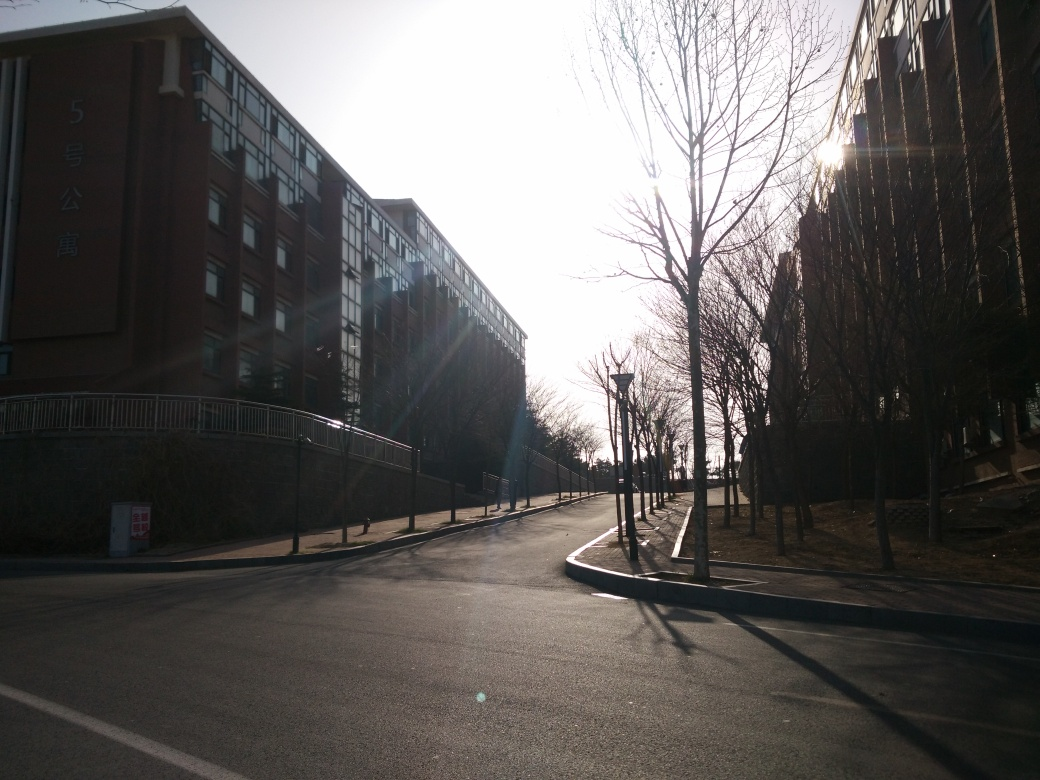What is the quality of the picture? The quality of the picture is good, with clear details visible despite some areas being overshadowed due to strong backlight. The dynamic range is slightly compromised with overexposed sections near the sun, but overall, the image is well-composed, showing a peaceful street view with the potential for better quality in more favorable lighting conditions. 